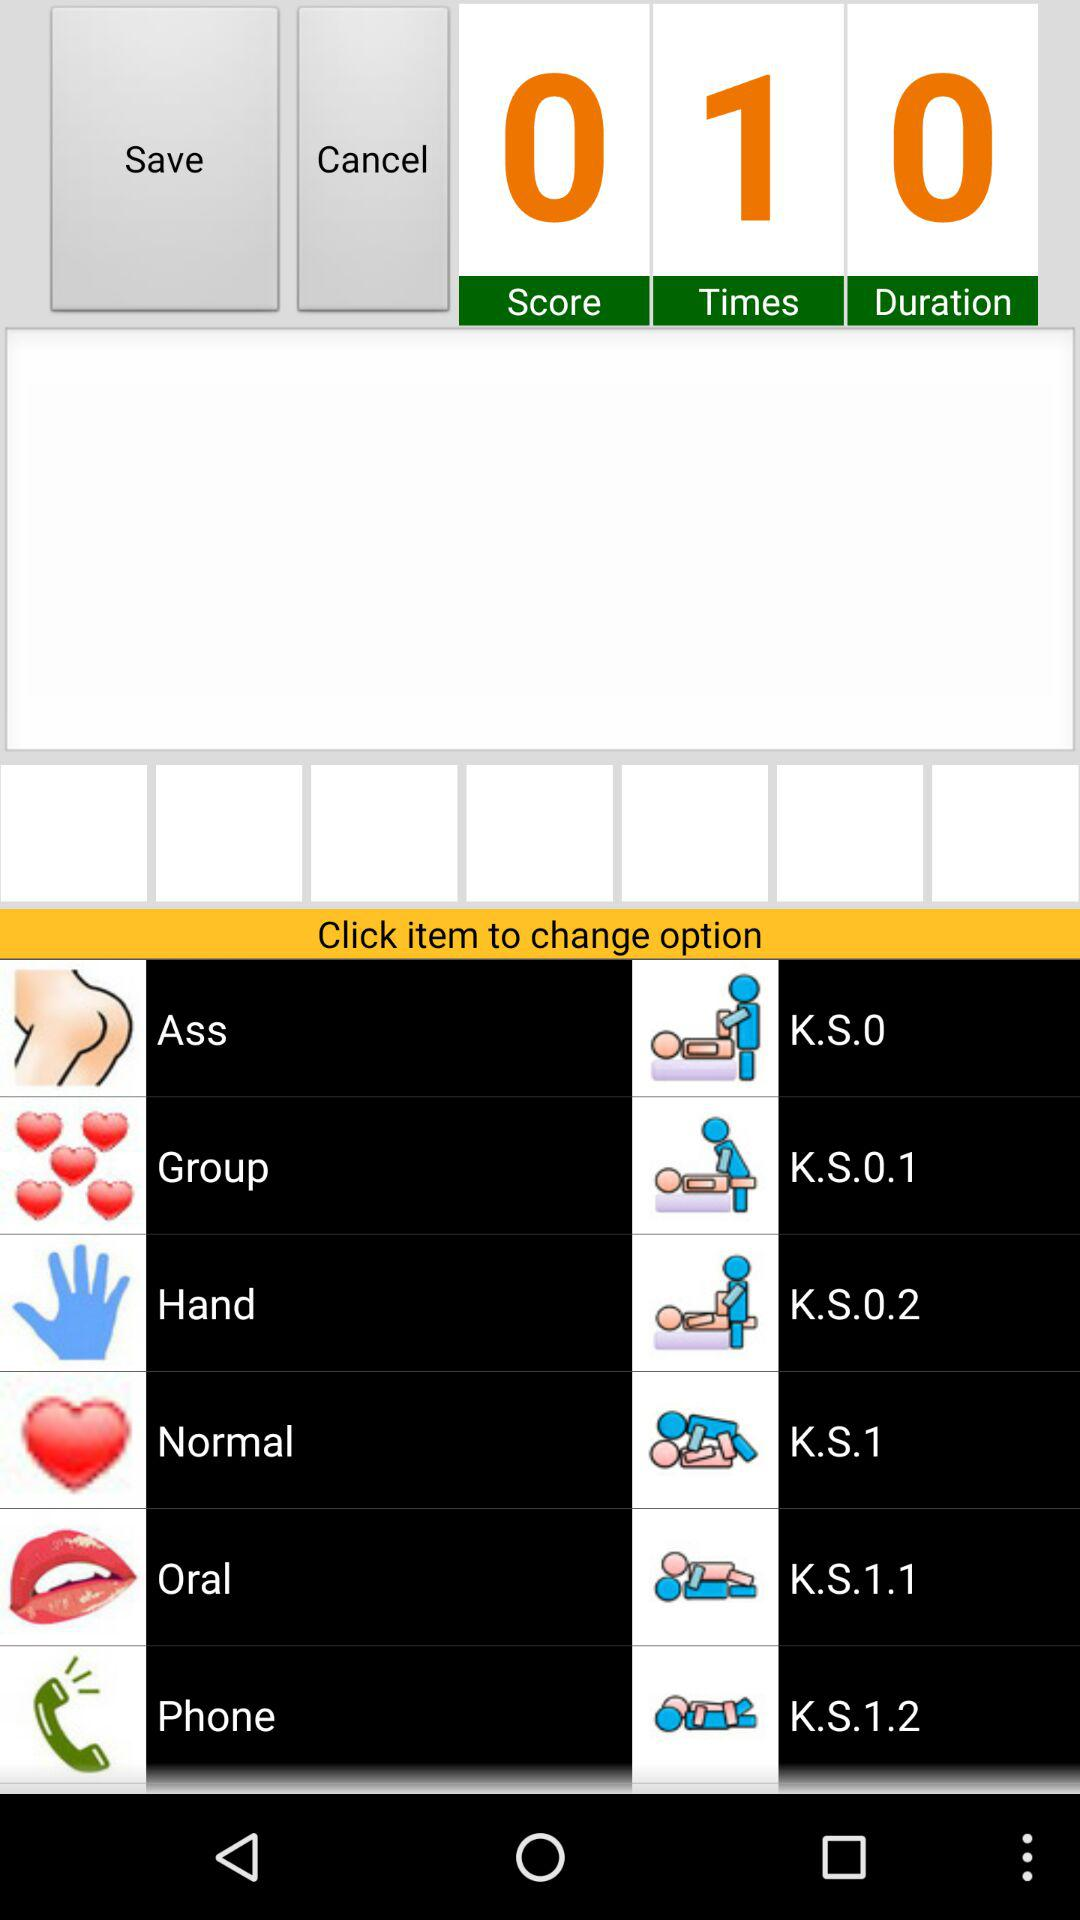What is the score? The score is 0. 